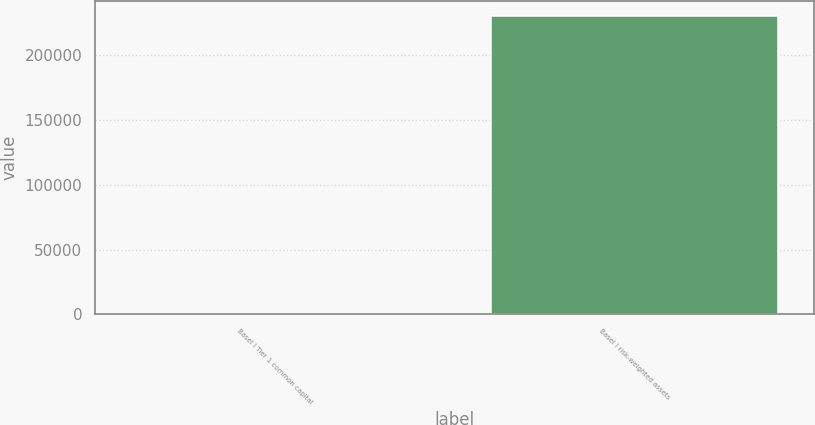<chart> <loc_0><loc_0><loc_500><loc_500><bar_chart><fcel>Basel I Tier 1 common capital<fcel>Basel I risk-weighted assets<nl><fcel>10.3<fcel>230705<nl></chart> 